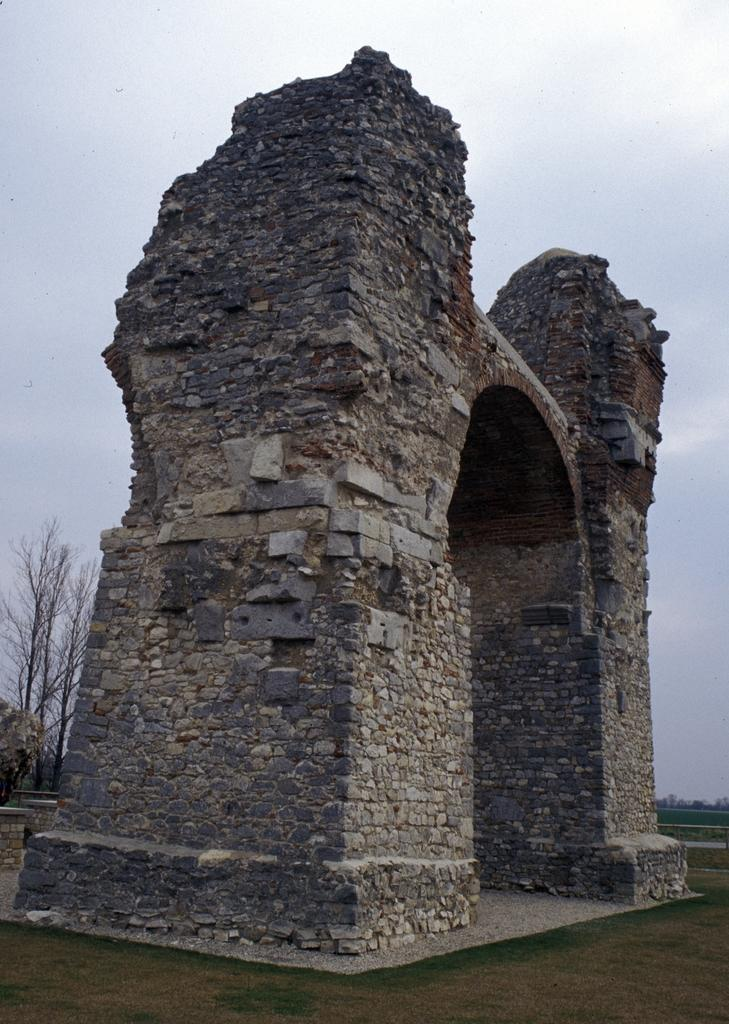What type of structure is present in the image? There is a rock gate in the image. What can be seen behind the rock gate? Trees are visible behind the rock gate. How many fingers can be seen on the rock gate in the image? There are no fingers present on the rock gate in the image. Is there a window visible in the image? There is no window present in the image. 